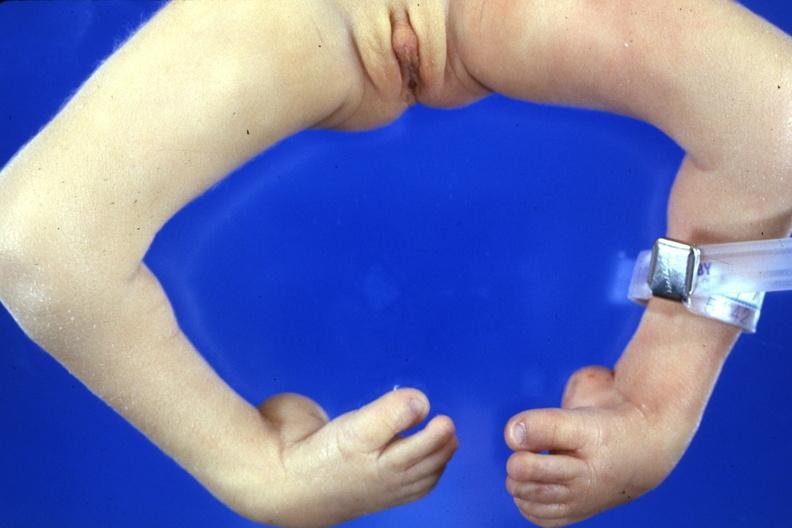how does this image show club feet?
Answer the question using a single word or phrase. With marked talipes equinovarus 